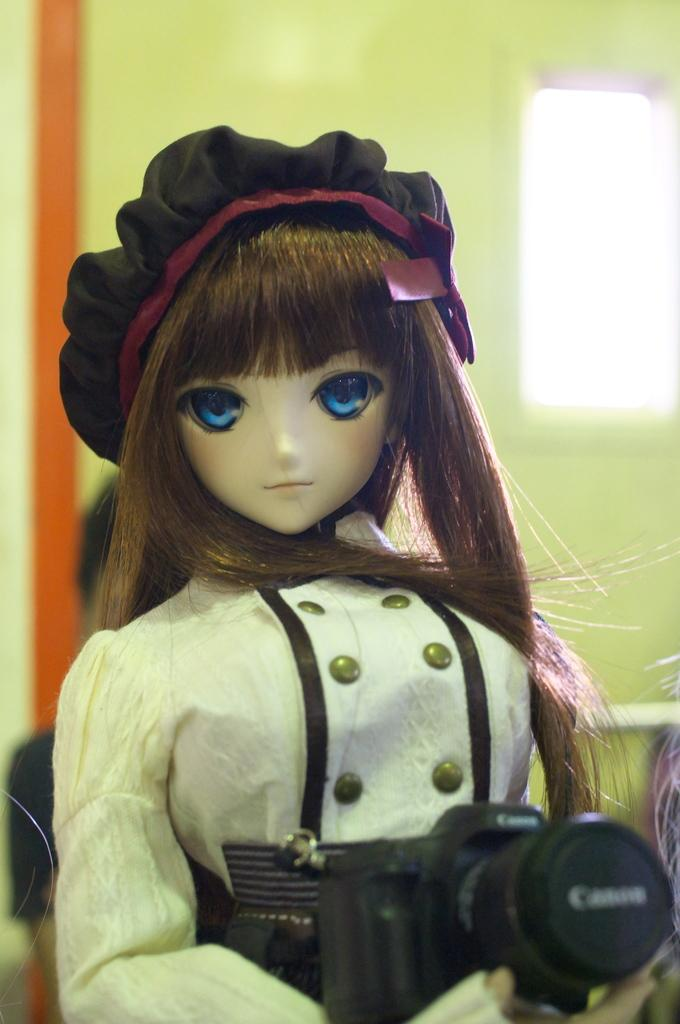What is the main subject of the image? There is a doll in the image. What is the doll holding in her hand? The doll is holding a camera in her hand. Can you describe the doll's appearance? The doll has long hair and is wearing a hat. What can be seen in the background of the image? There is a wall and a window in the background of the image. How many children are playing with the wooden horse in the image? There is no wooden horse or children present in the image; it features a doll holding a camera. 